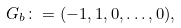<formula> <loc_0><loc_0><loc_500><loc_500>G _ { b } \colon = ( - 1 , 1 , 0 , \dots , 0 ) ,</formula> 